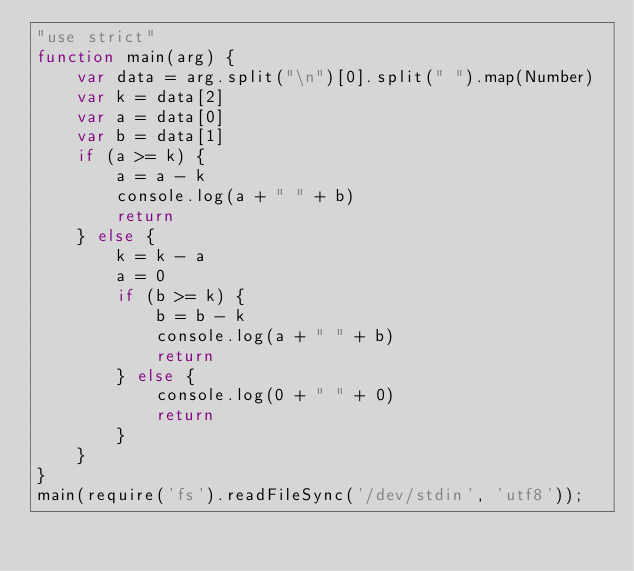Convert code to text. <code><loc_0><loc_0><loc_500><loc_500><_JavaScript_>"use strict"
function main(arg) {
    var data = arg.split("\n")[0].split(" ").map(Number)
    var k = data[2]
    var a = data[0]
    var b = data[1]
    if (a >= k) {
        a = a - k
        console.log(a + " " + b)
        return
    } else {
        k = k - a
        a = 0
        if (b >= k) {
            b = b - k
            console.log(a + " " + b)
            return 
        } else {
            console.log(0 + " " + 0)
            return
        }
    }
}
main(require('fs').readFileSync('/dev/stdin', 'utf8'));</code> 